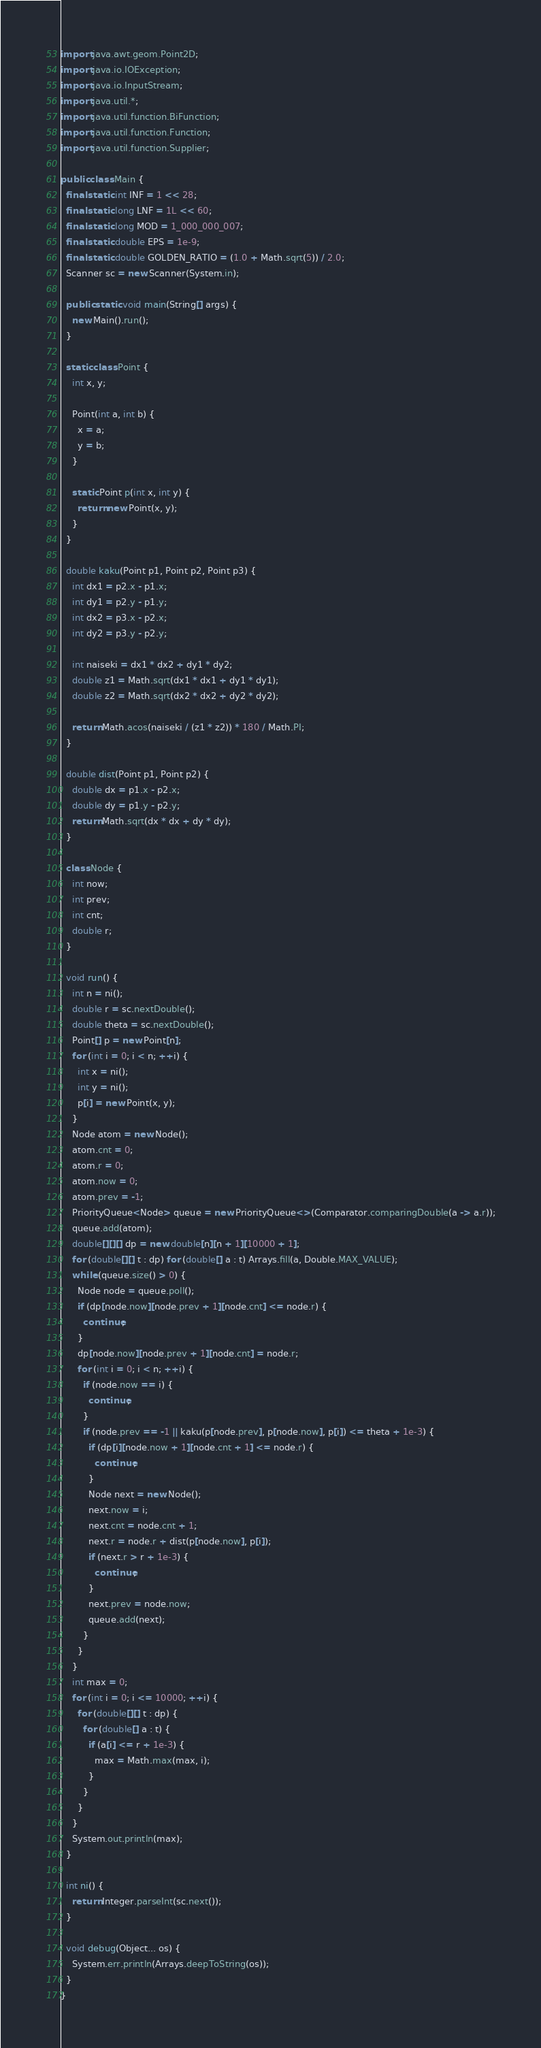<code> <loc_0><loc_0><loc_500><loc_500><_Java_>import java.awt.geom.Point2D;
import java.io.IOException;
import java.io.InputStream;
import java.util.*;
import java.util.function.BiFunction;
import java.util.function.Function;
import java.util.function.Supplier;

public class Main {
  final static int INF = 1 << 28;
  final static long LNF = 1L << 60;
  final static long MOD = 1_000_000_007;
  final static double EPS = 1e-9;
  final static double GOLDEN_RATIO = (1.0 + Math.sqrt(5)) / 2.0;
  Scanner sc = new Scanner(System.in);

  public static void main(String[] args) {
    new Main().run();
  }

  static class Point {
    int x, y;

    Point(int a, int b) {
      x = a;
      y = b;
    }

    static Point p(int x, int y) {
      return new Point(x, y);
    }
  }

  double kaku(Point p1, Point p2, Point p3) {
    int dx1 = p2.x - p1.x;
    int dy1 = p2.y - p1.y;
    int dx2 = p3.x - p2.x;
    int dy2 = p3.y - p2.y;

    int naiseki = dx1 * dx2 + dy1 * dy2;
    double z1 = Math.sqrt(dx1 * dx1 + dy1 * dy1);
    double z2 = Math.sqrt(dx2 * dx2 + dy2 * dy2);

    return Math.acos(naiseki / (z1 * z2)) * 180 / Math.PI;
  }

  double dist(Point p1, Point p2) {
    double dx = p1.x - p2.x;
    double dy = p1.y - p2.y;
    return Math.sqrt(dx * dx + dy * dy);
  }

  class Node {
    int now;
    int prev;
    int cnt;
    double r;
  }

  void run() {
    int n = ni();
    double r = sc.nextDouble();
    double theta = sc.nextDouble();
    Point[] p = new Point[n];
    for (int i = 0; i < n; ++i) {
      int x = ni();
      int y = ni();
      p[i] = new Point(x, y);
    }
    Node atom = new Node();
    atom.cnt = 0;
    atom.r = 0;
    atom.now = 0;
    atom.prev = -1;
    PriorityQueue<Node> queue = new PriorityQueue<>(Comparator.comparingDouble(a -> a.r));
    queue.add(atom);
    double[][][] dp = new double[n][n + 1][10000 + 1];
    for (double[][] t : dp) for (double[] a : t) Arrays.fill(a, Double.MAX_VALUE);
    while (queue.size() > 0) {
      Node node = queue.poll();
      if (dp[node.now][node.prev + 1][node.cnt] <= node.r) {
        continue;
      }
      dp[node.now][node.prev + 1][node.cnt] = node.r;
      for (int i = 0; i < n; ++i) {
        if (node.now == i) {
          continue;
        }
        if (node.prev == -1 || kaku(p[node.prev], p[node.now], p[i]) <= theta + 1e-3) {
          if (dp[i][node.now + 1][node.cnt + 1] <= node.r) {
            continue;
          }
          Node next = new Node();
          next.now = i;
          next.cnt = node.cnt + 1;
          next.r = node.r + dist(p[node.now], p[i]);
          if (next.r > r + 1e-3) {
            continue;
          }
          next.prev = node.now;
          queue.add(next);
        }
      }
    }
    int max = 0;
    for (int i = 0; i <= 10000; ++i) {
      for (double[][] t : dp) {
        for (double[] a : t) {
          if (a[i] <= r + 1e-3) {
            max = Math.max(max, i);
          }
        }
      }
    }
    System.out.println(max);
  }

  int ni() {
    return Integer.parseInt(sc.next());
  }

  void debug(Object... os) {
    System.err.println(Arrays.deepToString(os));
  }
}</code> 